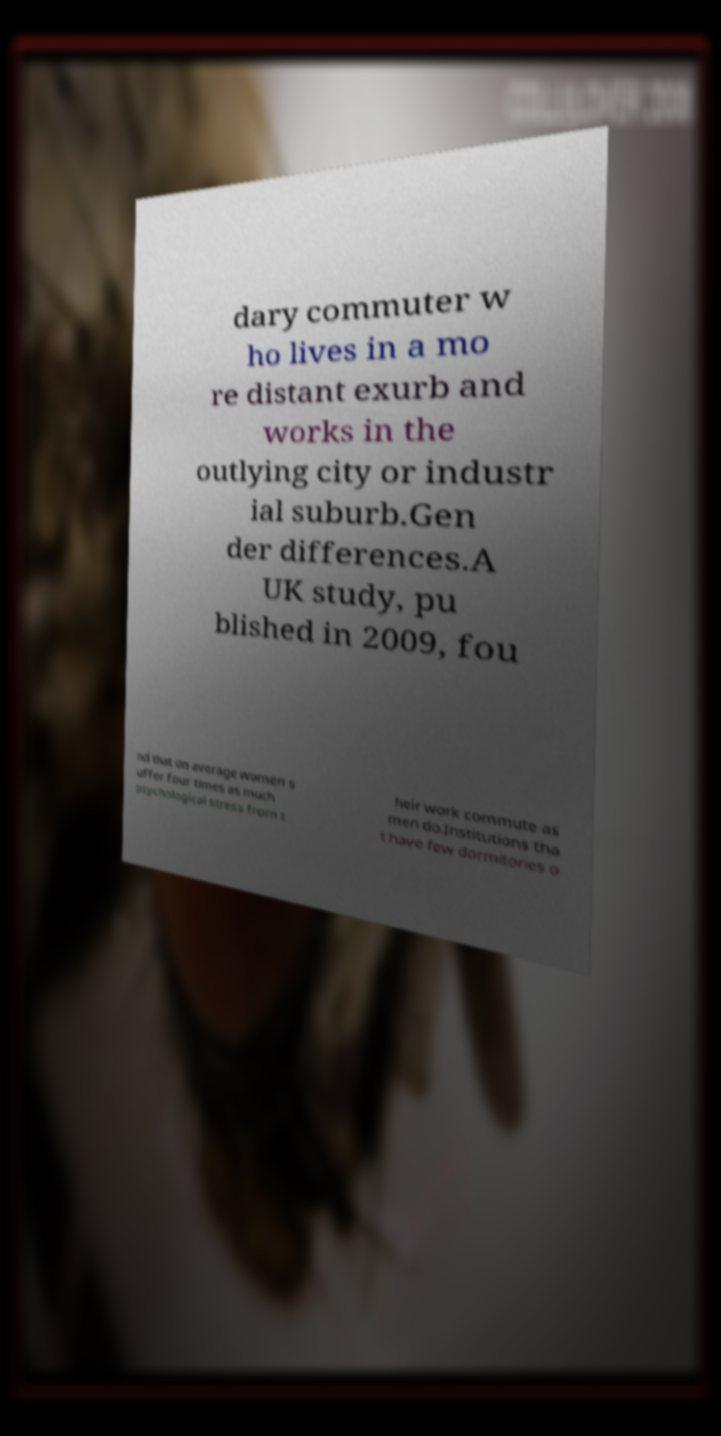Please identify and transcribe the text found in this image. dary commuter w ho lives in a mo re distant exurb and works in the outlying city or industr ial suburb.Gen der differences.A UK study, pu blished in 2009, fou nd that on average women s uffer four times as much psychological stress from t heir work commute as men do.Institutions tha t have few dormitories o 